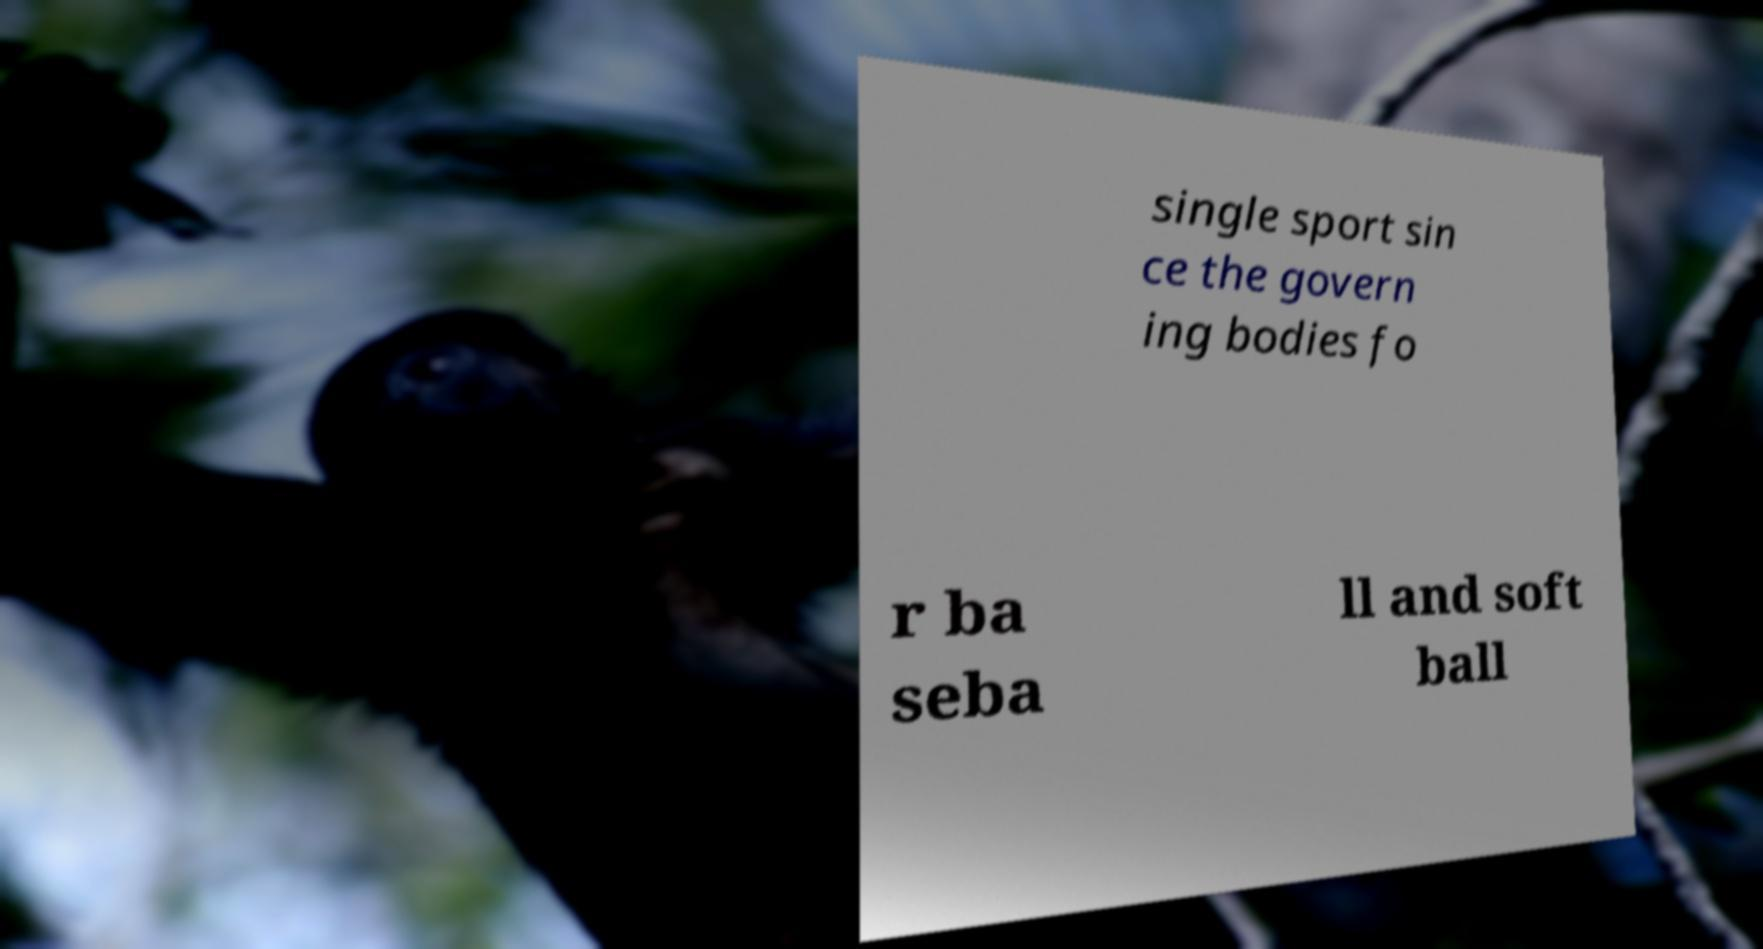Could you extract and type out the text from this image? single sport sin ce the govern ing bodies fo r ba seba ll and soft ball 